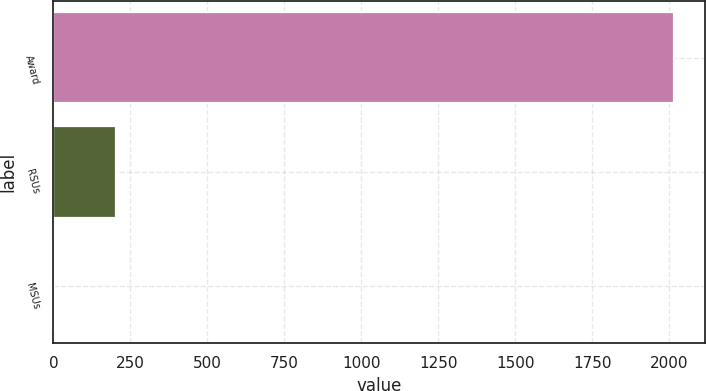Convert chart. <chart><loc_0><loc_0><loc_500><loc_500><bar_chart><fcel>Award<fcel>RSUs<fcel>MSUs<nl><fcel>2016<fcel>204.3<fcel>3<nl></chart> 